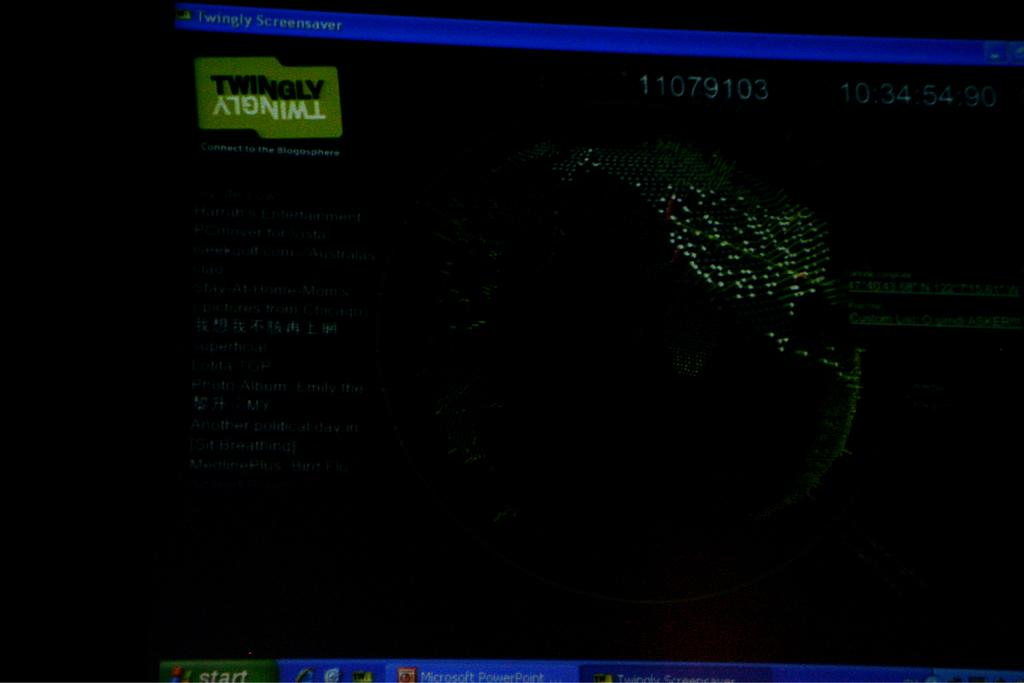<image>
Summarize the visual content of the image. The word Twingly is visible to the top left of a darkened screen 